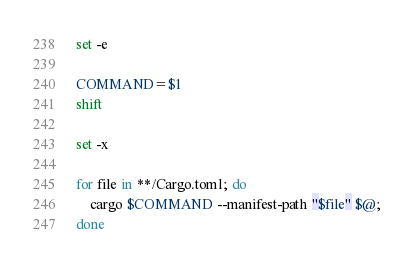Convert code to text. <code><loc_0><loc_0><loc_500><loc_500><_Bash_>
set -e

COMMAND=$1
shift

set -x

for file in **/Cargo.toml; do
	cargo $COMMAND --manifest-path "$file" $@;
done

</code> 